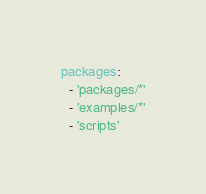<code> <loc_0><loc_0><loc_500><loc_500><_YAML_>packages:
  - 'packages/*'
  - 'examples/*'
  - 'scripts'
</code> 